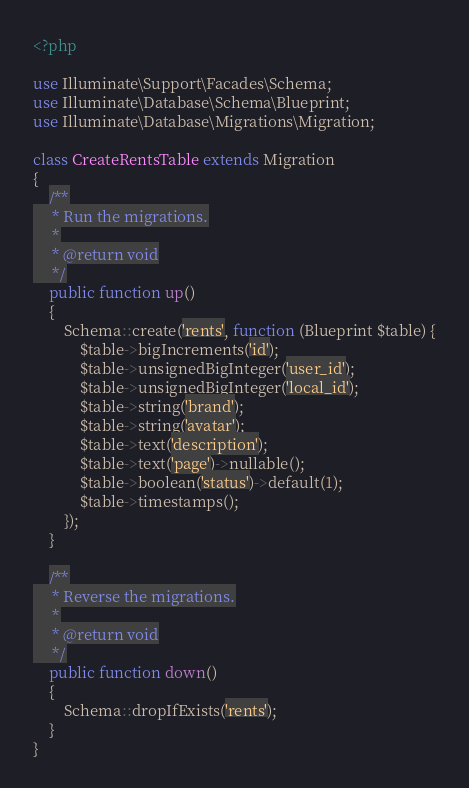<code> <loc_0><loc_0><loc_500><loc_500><_PHP_><?php

use Illuminate\Support\Facades\Schema;
use Illuminate\Database\Schema\Blueprint;
use Illuminate\Database\Migrations\Migration;

class CreateRentsTable extends Migration
{
    /**
     * Run the migrations.
     *
     * @return void
     */
    public function up()
    {
        Schema::create('rents', function (Blueprint $table) {
            $table->bigIncrements('id');
            $table->unsignedBigInteger('user_id');
            $table->unsignedBigInteger('local_id');
            $table->string('brand');
            $table->string('avatar');
            $table->text('description');
            $table->text('page')->nullable();
            $table->boolean('status')->default(1);
            $table->timestamps();
        });
    }

    /**
     * Reverse the migrations.
     *
     * @return void
     */
    public function down()
    {
        Schema::dropIfExists('rents');
    }
}
</code> 